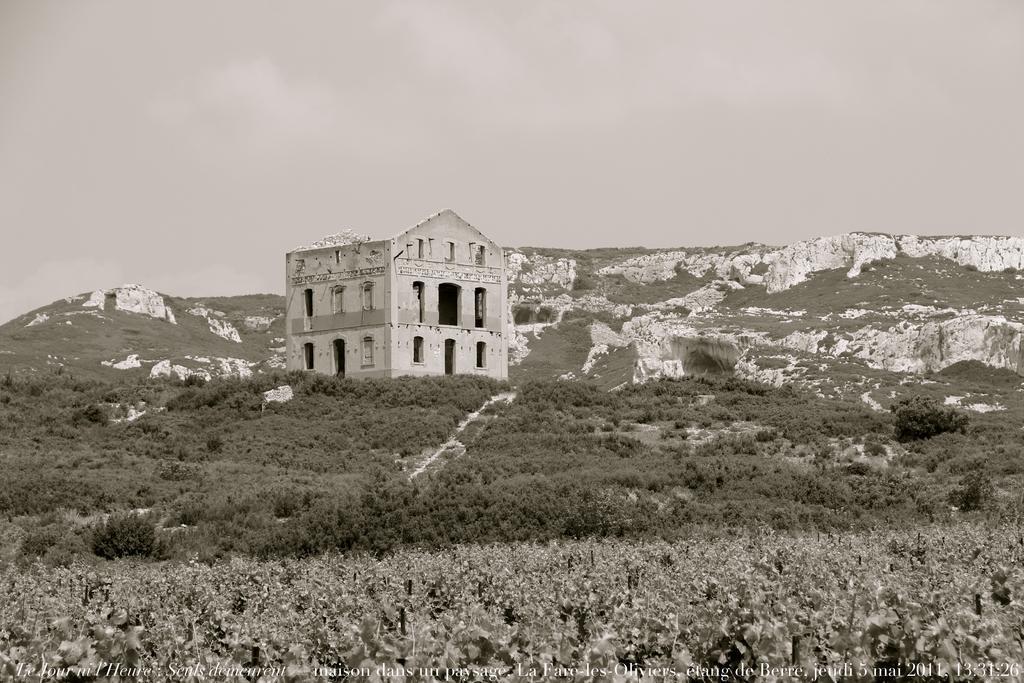How would you summarize this image in a sentence or two? In this image I can see number of trees and a building. In the background I can see few mountains and the sky. 